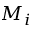<formula> <loc_0><loc_0><loc_500><loc_500>M _ { i }</formula> 